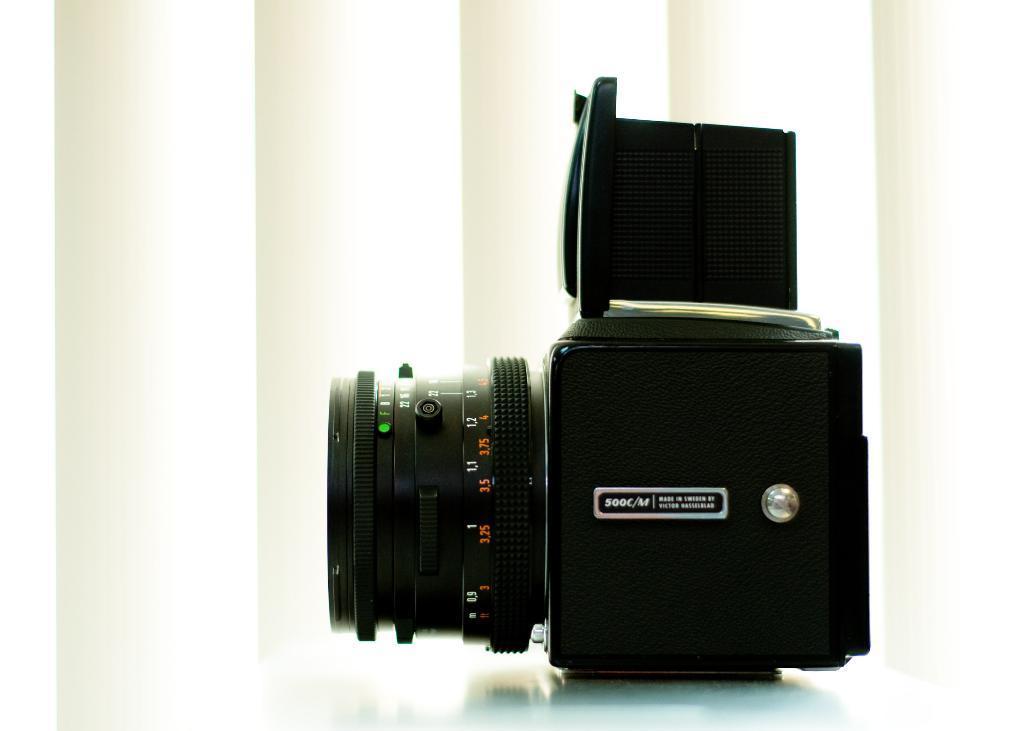How would you summarize this image in a sentence or two? Here we can see a camera on a platform and there is a white background. 